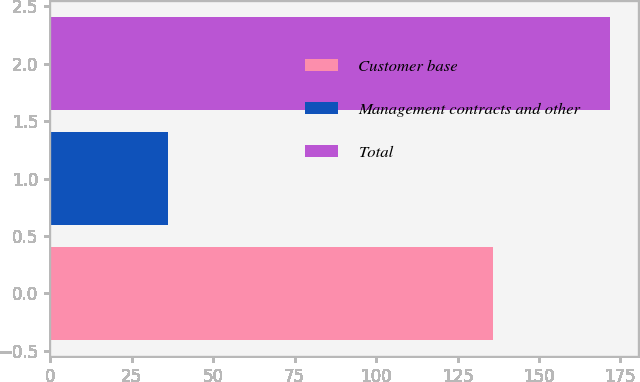Convert chart. <chart><loc_0><loc_0><loc_500><loc_500><bar_chart><fcel>Customer base<fcel>Management contracts and other<fcel>Total<nl><fcel>135.9<fcel>36<fcel>171.9<nl></chart> 